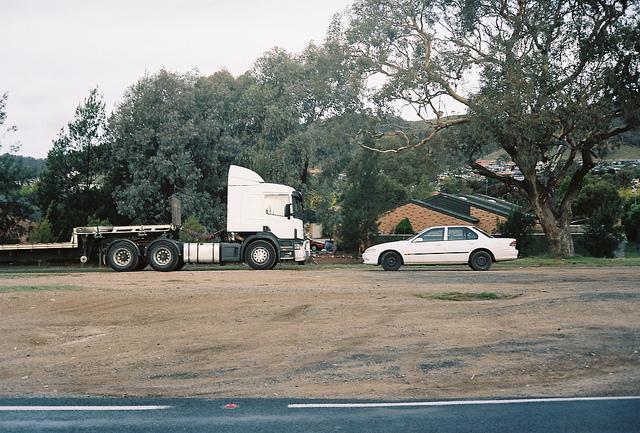What is this type of truck called?
Choose the right answer and clarify with the format: 'Answer: answer
Rationale: rationale.'
Options: Dump truck, cement truck, semi, pickup. Answer: semi.
Rationale: The truck is semi. 